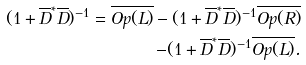Convert formula to latex. <formula><loc_0><loc_0><loc_500><loc_500>( 1 + \overline { D } ^ { * } \overline { D } ) ^ { - 1 } = \overline { O p ( L ) } - ( 1 + \overline { D } ^ { * } \overline { D } ) ^ { - 1 } \overline { O p ( R ) } \\ - ( 1 + \overline { D } ^ { * } \overline { D } ) ^ { - 1 } \overline { O p ( L ) } .</formula> 